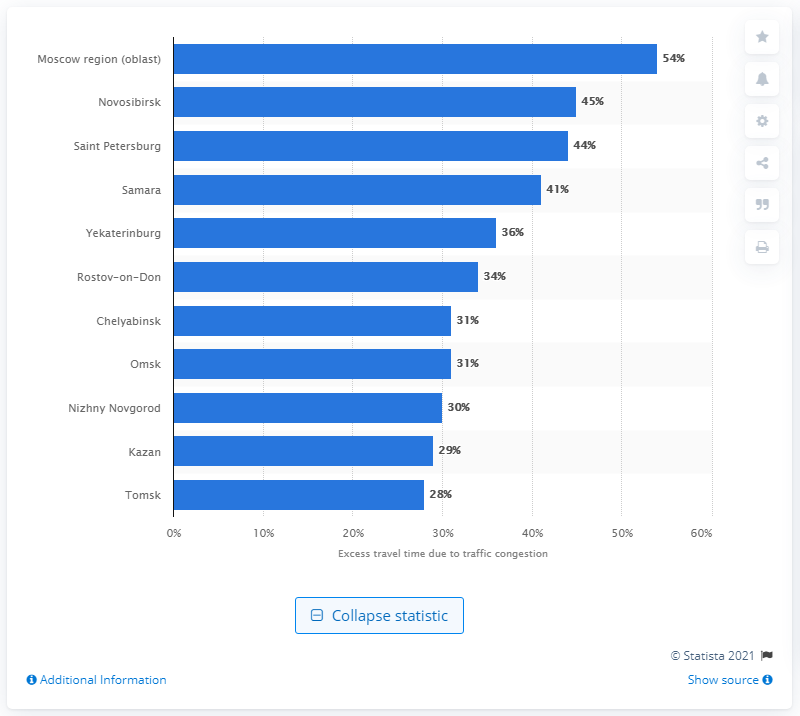Give some essential details in this illustration. The increase in traffic jams in Moscow led to a significant increase in travel time, with an estimated increase of 54%. The congestion level in Saint Petersburg was 44%. 